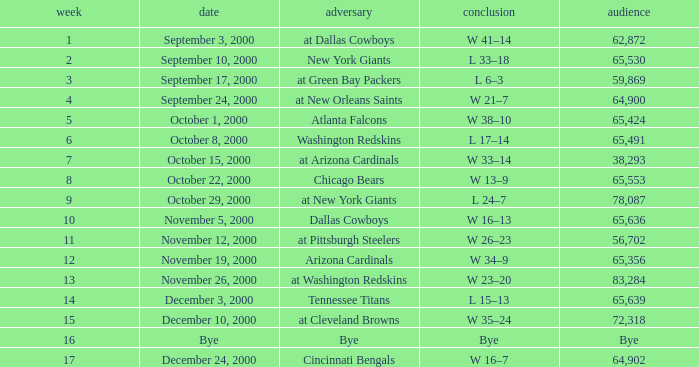What was the attendance when the Cincinnati Bengals were the opponents? 64902.0. 